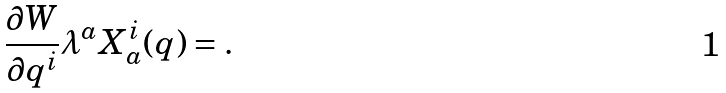Convert formula to latex. <formula><loc_0><loc_0><loc_500><loc_500>\frac { \partial W } { \partial q ^ { i } } \lambda ^ { a } X _ { a } ^ { i } ( q ) = .</formula> 